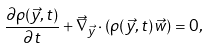Convert formula to latex. <formula><loc_0><loc_0><loc_500><loc_500>\frac { \partial \rho ( \vec { y } , t ) } { \partial t } + \vec { \nabla } _ { \vec { y } } \cdot ( \rho ( \vec { y } , t ) \vec { w } ) = 0 ,</formula> 